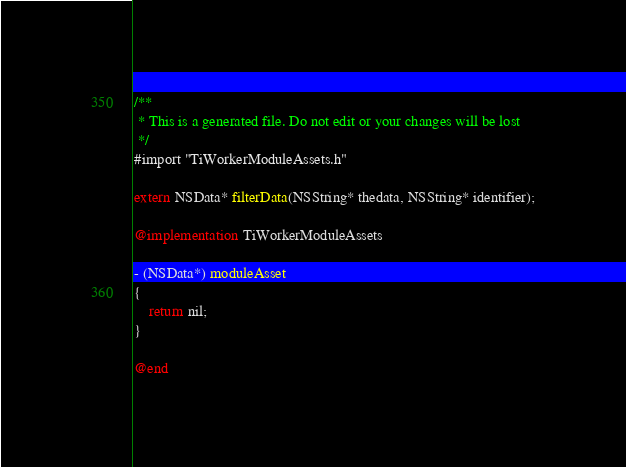Convert code to text. <code><loc_0><loc_0><loc_500><loc_500><_ObjectiveC_>/**
 * This is a generated file. Do not edit or your changes will be lost
 */
#import "TiWorkerModuleAssets.h"

extern NSData* filterData(NSString* thedata, NSString* identifier);

@implementation TiWorkerModuleAssets

- (NSData*) moduleAsset
{
	return nil;
}

@end
</code> 